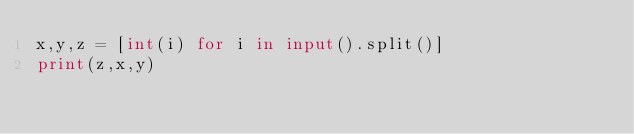Convert code to text. <code><loc_0><loc_0><loc_500><loc_500><_Python_>x,y,z = [int(i) for i in input().split()]
print(z,x,y)</code> 